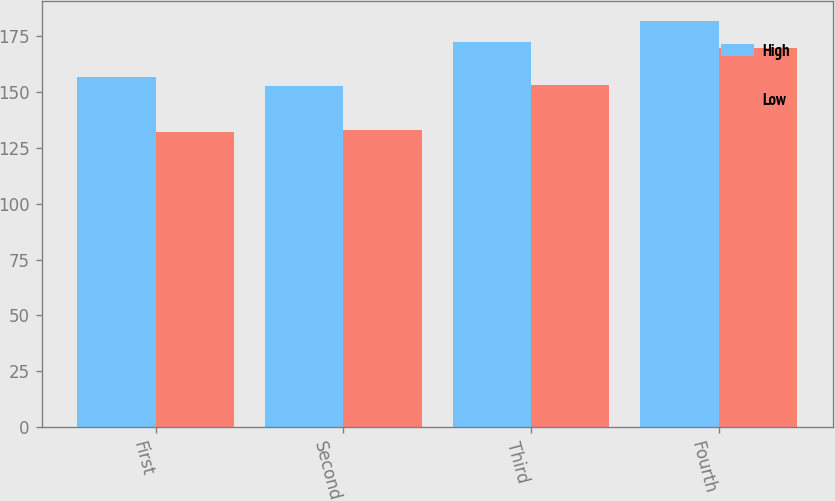Convert chart. <chart><loc_0><loc_0><loc_500><loc_500><stacked_bar_chart><ecel><fcel>First<fcel>Second<fcel>Third<fcel>Fourth<nl><fcel>High<fcel>156.53<fcel>152.54<fcel>172.19<fcel>181.55<nl><fcel>Low<fcel>132.19<fcel>132.88<fcel>152.86<fcel>169.64<nl></chart> 